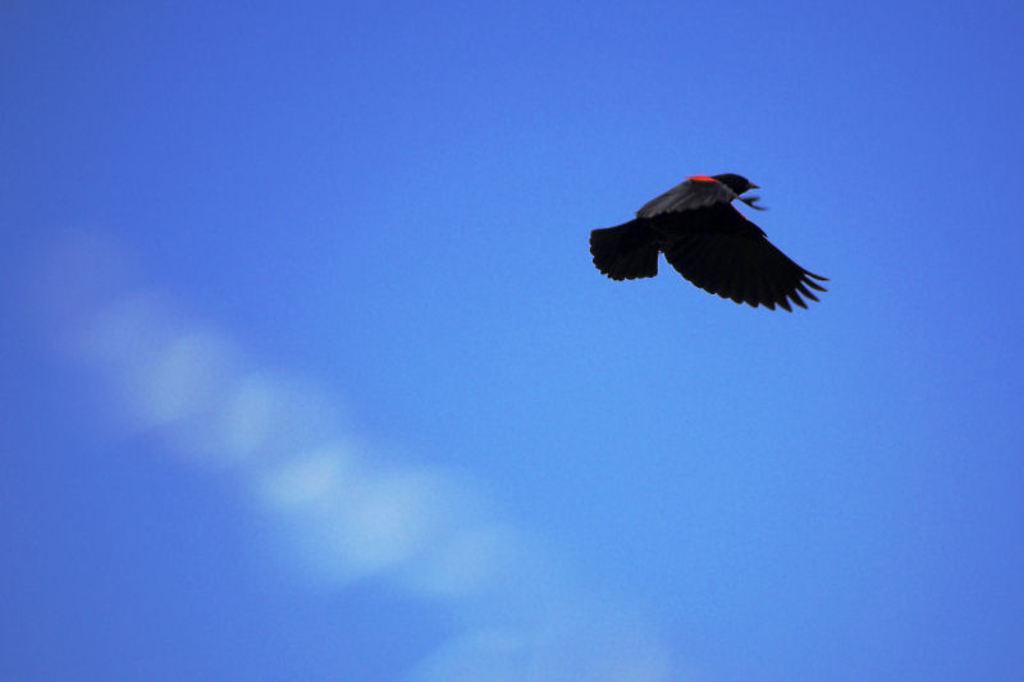What type of animal can be seen in the image? There is a bird in the image. What is the bird doing in the image? The bird is flying in the sky. How many friends is the bird talking to in the image? There is no indication in the image that the bird is talking to any friends. What type of weapon is present in the image? There is no weapon, such as a cannon, present in the image. What part of the bird's body is visible in the image? The image only shows the bird flying in the sky, so it is not possible to determine which specific part of the bird's body is visible. 